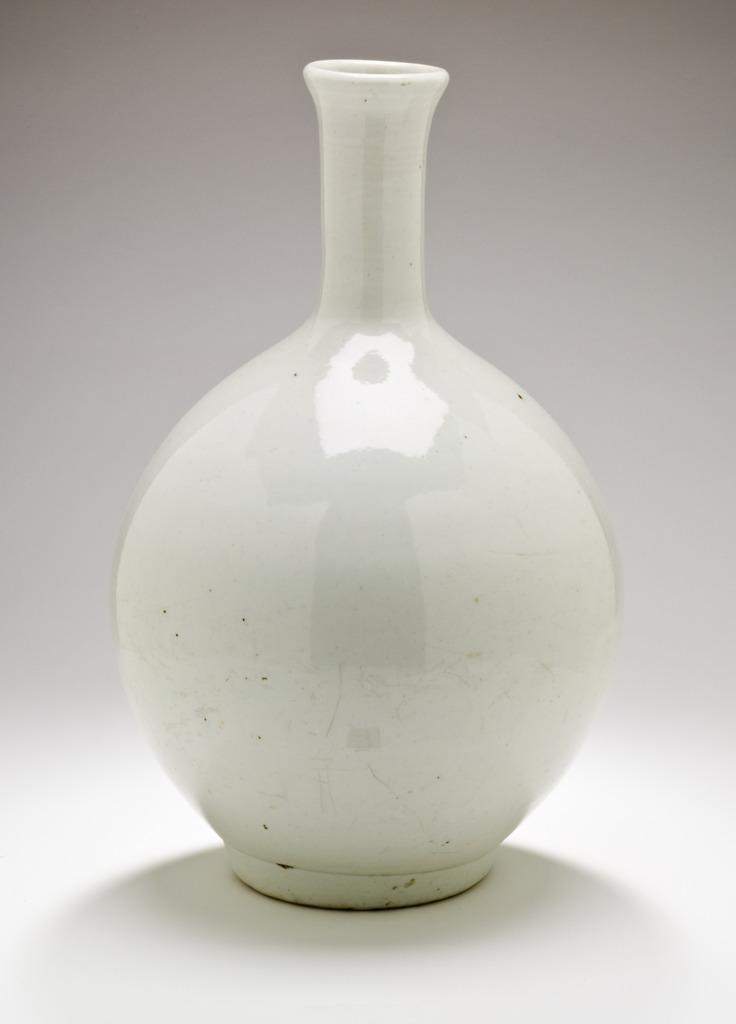What object is present in the image? There is a pot in the image. What material is the pot made of? The pot is made up of ceramic. Where is the playground located in the image? There is no playground present in the image; it only features a pot made of ceramic. Can you see a worm crawling on the pot in the image? There is no worm present in the image; it only features a pot made of ceramic. 